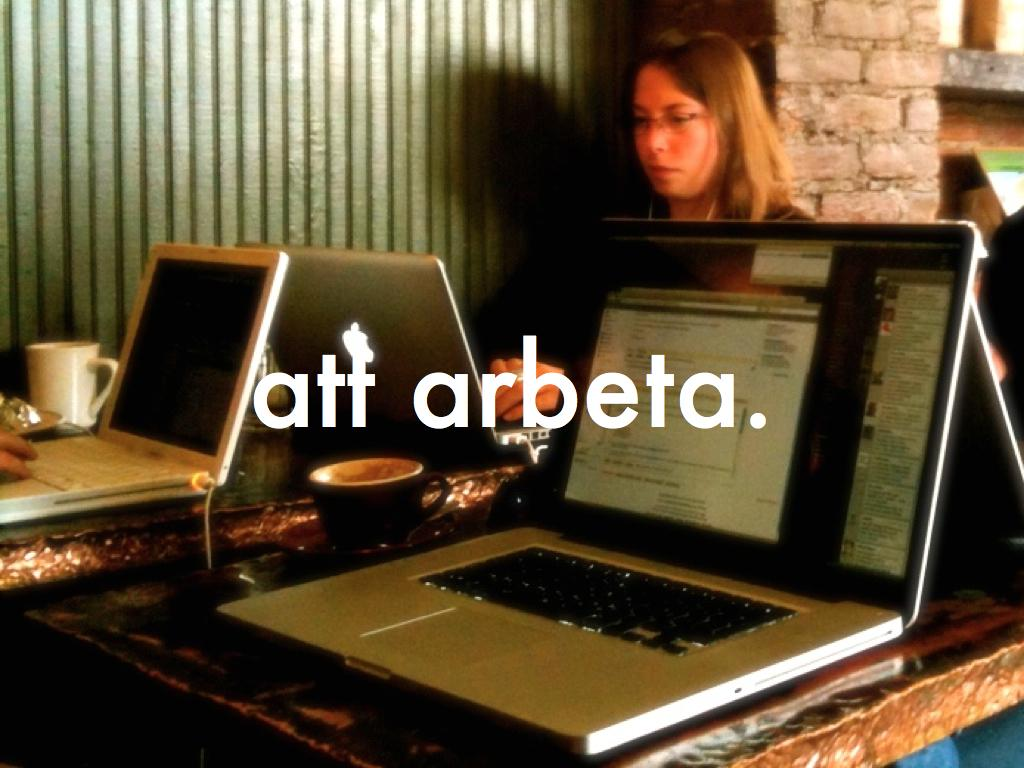Who is present in the image? There is a woman in the image. What objects are on the table in the image? There are laptops and cups on a table in the image. What can be seen in the center of the image? There is a watermark in the center of the image. What is visible in the background of the image? There is a wall in the background of the image. What type of mint is growing near the mailbox in the image? There is no mint or mailbox present in the image. 